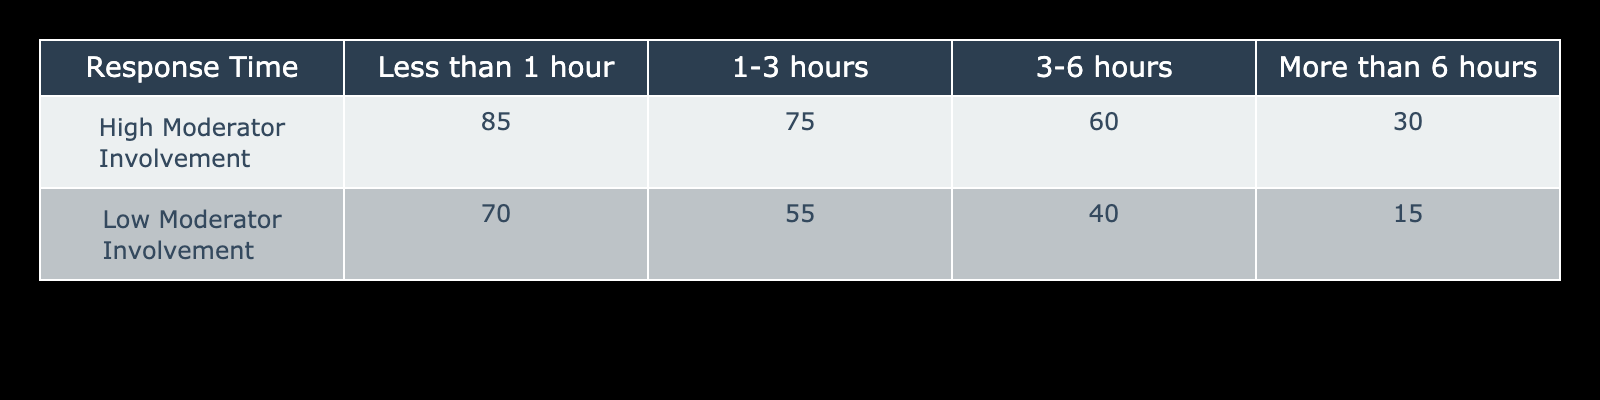What is the user satisfaction rating for high moderator involvement with a response time of less than 1 hour? The table shows the cell corresponding to "High Moderator Involvement" and "Less than 1 hour." The value is 85.
Answer: 85 What is the user satisfaction rating for low moderator involvement with a response time of more than 6 hours? The table displays the cell for "Low Moderator Involvement" under "More than 6 hours." The value found is 15.
Answer: 15 Which response time has the highest user satisfaction rating for low moderator involvement? For low moderator involvement, the ratings listed are 70, 55, 40, and 15, respectively for "Less than 1 hour," "1-3 hours," "3-6 hours," and "More than 6 hours." The highest rating is 70 for "Less than 1 hour."
Answer: 70 What is the difference in user satisfaction ratings between high and low moderator involvement for response times of 1-3 hours? The rating for high moderator involvement is 75 and for low moderator involvement is 55. The difference is calculated as 75 - 55 = 20.
Answer: 20 Is the user satisfaction rating for high moderator involvement greater than that for low moderator involvement in the 3-6 hours category? In the 3-6 hours category, the rating for high involvement is 60 and for low involvement is 40. Since 60 is greater than 40, the answer is yes.
Answer: Yes Which category has the lowest user satisfaction rating overall? Evaluating all ratings, the lowest value in the table is 15, found in the "Low Moderator Involvement" and "More than 6 hours" category.
Answer: Low moderator involvement, more than 6 hours What is the average user satisfaction rating for high moderator involvement across all response times? The ratings for high moderator involvement are 85, 75, 60, and 30. The sum is 85 + 75 + 60 + 30 = 250. Since there are 4 ratings, the average is 250 / 4 = 62.5.
Answer: 62.5 For low moderator involvement, is the user satisfaction rating for response times of 3-6 hours more than half of the rating for response times of less than 1 hour? The rating for 3-6 hours is 40 and for less than 1 hour is 70. Half of 70 is 35, and since 40 is greater than 35, the answer is yes.
Answer: Yes What is the total user satisfaction rating for both categories of moderator involvement for response times of less than 1 hour? For less than 1 hour, the ratings are 85 (high) and 70 (low). Summing these gives 85 + 70 = 155.
Answer: 155 